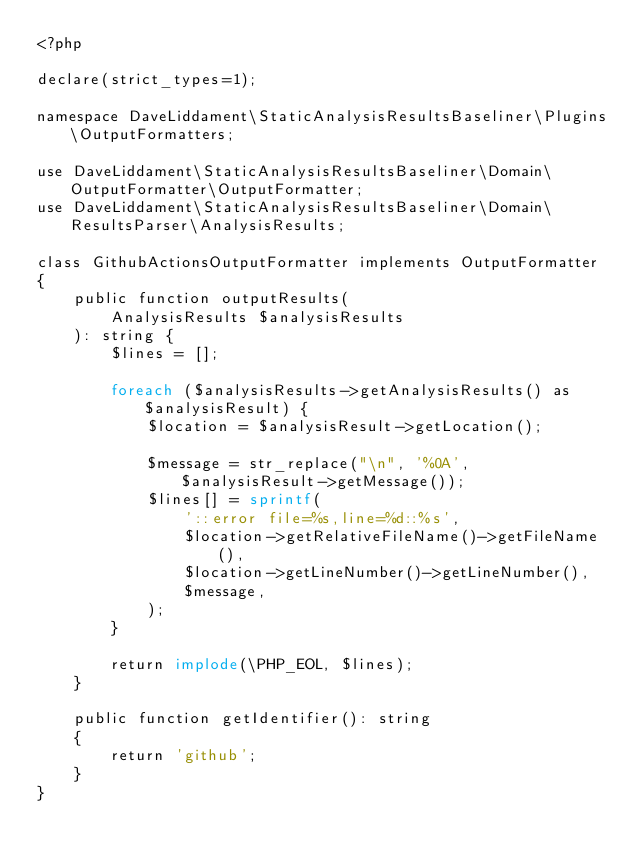Convert code to text. <code><loc_0><loc_0><loc_500><loc_500><_PHP_><?php

declare(strict_types=1);

namespace DaveLiddament\StaticAnalysisResultsBaseliner\Plugins\OutputFormatters;

use DaveLiddament\StaticAnalysisResultsBaseliner\Domain\OutputFormatter\OutputFormatter;
use DaveLiddament\StaticAnalysisResultsBaseliner\Domain\ResultsParser\AnalysisResults;

class GithubActionsOutputFormatter implements OutputFormatter
{
    public function outputResults(
        AnalysisResults $analysisResults
    ): string {
        $lines = [];

        foreach ($analysisResults->getAnalysisResults() as $analysisResult) {
            $location = $analysisResult->getLocation();

            $message = str_replace("\n", '%0A', $analysisResult->getMessage());
            $lines[] = sprintf(
                '::error file=%s,line=%d::%s',
                $location->getRelativeFileName()->getFileName(),
                $location->getLineNumber()->getLineNumber(),
                $message,
            );
        }

        return implode(\PHP_EOL, $lines);
    }

    public function getIdentifier(): string
    {
        return 'github';
    }
}
</code> 